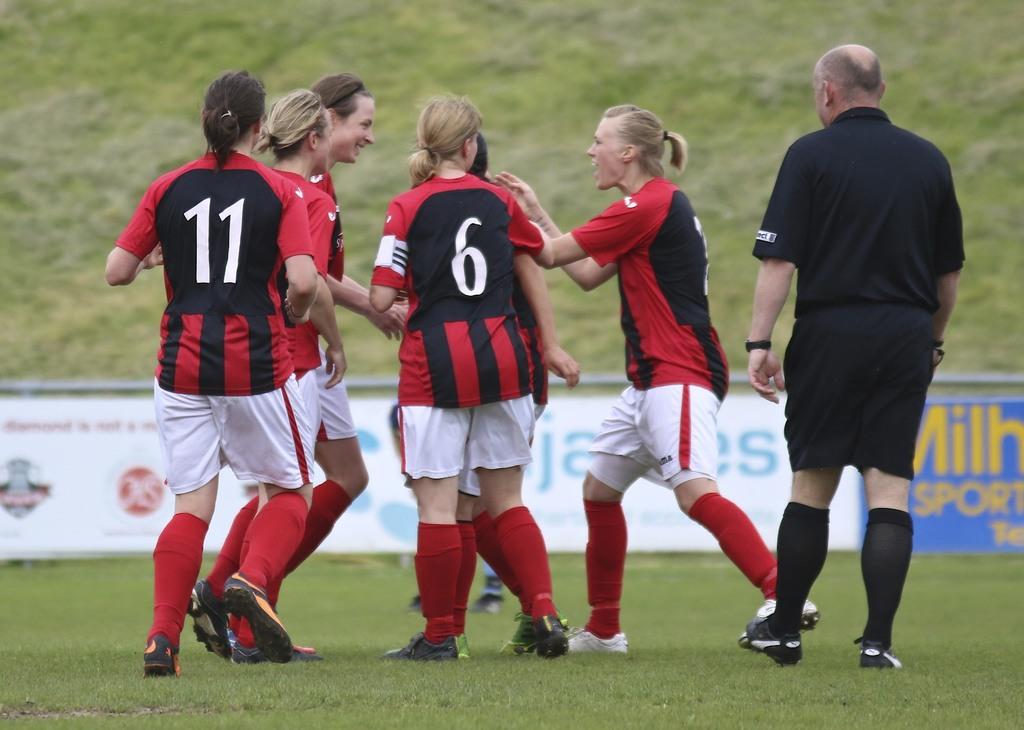What do the two jersey numbers add up to?
Ensure brevity in your answer.  17. What number is the girl on the left?
Your answer should be very brief. 11. 